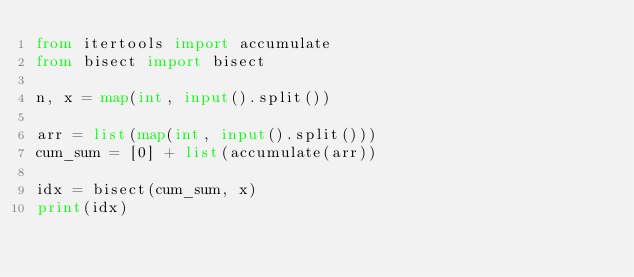Convert code to text. <code><loc_0><loc_0><loc_500><loc_500><_Python_>from itertools import accumulate
from bisect import bisect

n, x = map(int, input().split())

arr = list(map(int, input().split()))
cum_sum = [0] + list(accumulate(arr))

idx = bisect(cum_sum, x)
print(idx)
</code> 